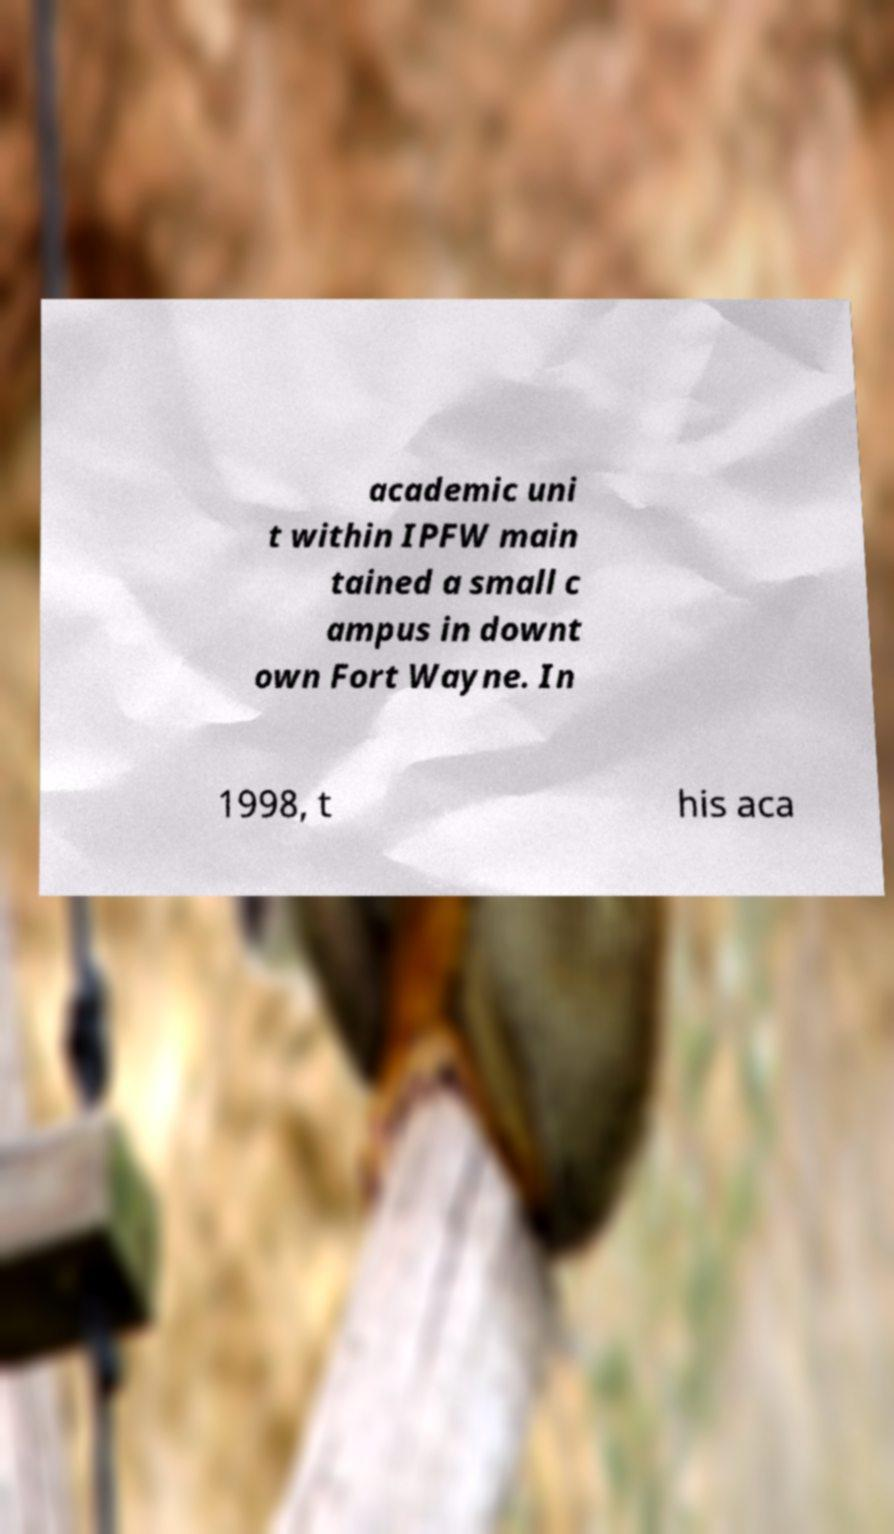For documentation purposes, I need the text within this image transcribed. Could you provide that? academic uni t within IPFW main tained a small c ampus in downt own Fort Wayne. In 1998, t his aca 